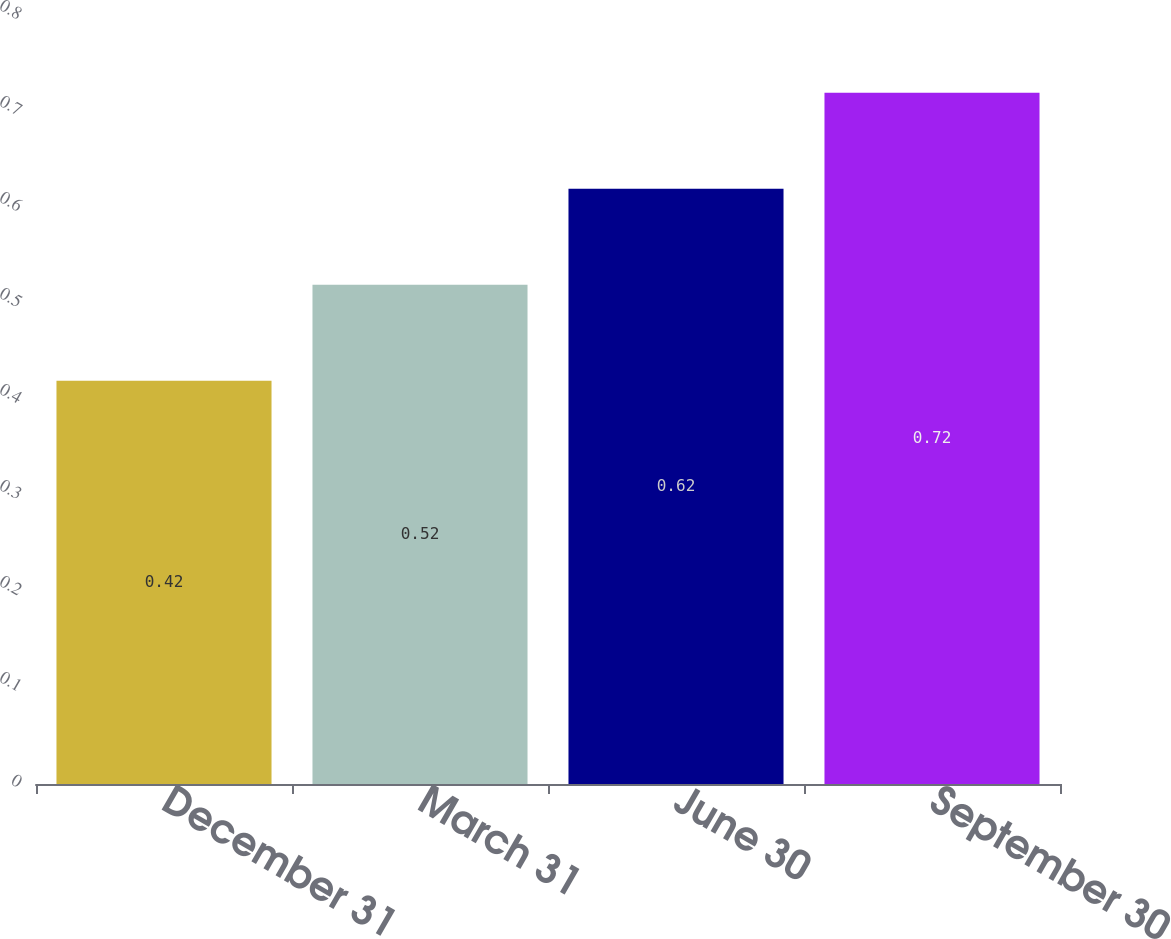<chart> <loc_0><loc_0><loc_500><loc_500><bar_chart><fcel>December 31<fcel>March 31<fcel>June 30<fcel>September 30<nl><fcel>0.42<fcel>0.52<fcel>0.62<fcel>0.72<nl></chart> 